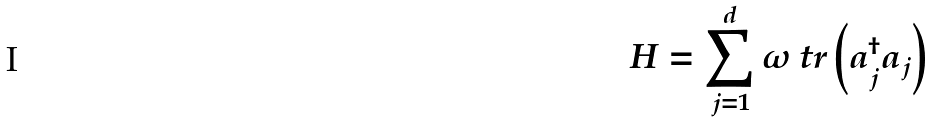Convert formula to latex. <formula><loc_0><loc_0><loc_500><loc_500>H = \sum _ { j = 1 } ^ { d } \omega \ t r \left ( a _ { j } ^ { \dagger } a _ { j } \right )</formula> 